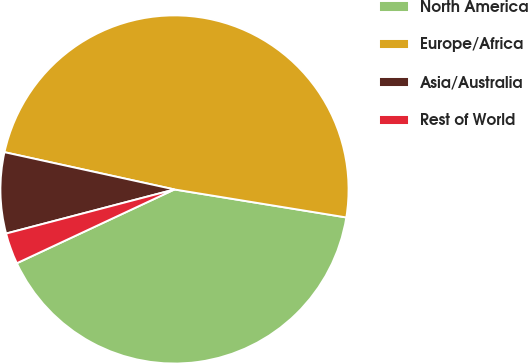Convert chart. <chart><loc_0><loc_0><loc_500><loc_500><pie_chart><fcel>North America<fcel>Europe/Africa<fcel>Asia/Australia<fcel>Rest of World<nl><fcel>40.46%<fcel>49.13%<fcel>7.51%<fcel>2.89%<nl></chart> 